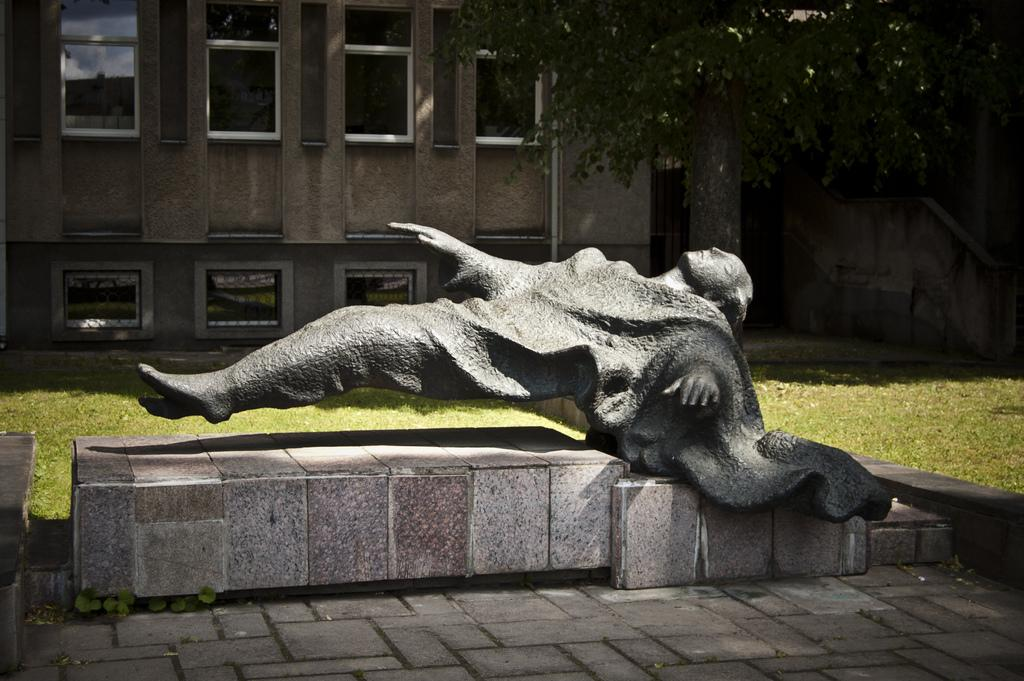What is the main subject of the image? There is a grey color sculpture in the image. What can be seen in the background of the image? There is grass, a tree, and a building in the background of the image. Are there any visible openings in the building? Yes, there are windows visible in the background of the image. How many clocks are hanging from the tree in the image? There are no clocks hanging from the tree in the image. What type of base is supporting the sculpture in the image? The provided facts do not mention a base supporting the sculpture, so we cannot determine its type. 